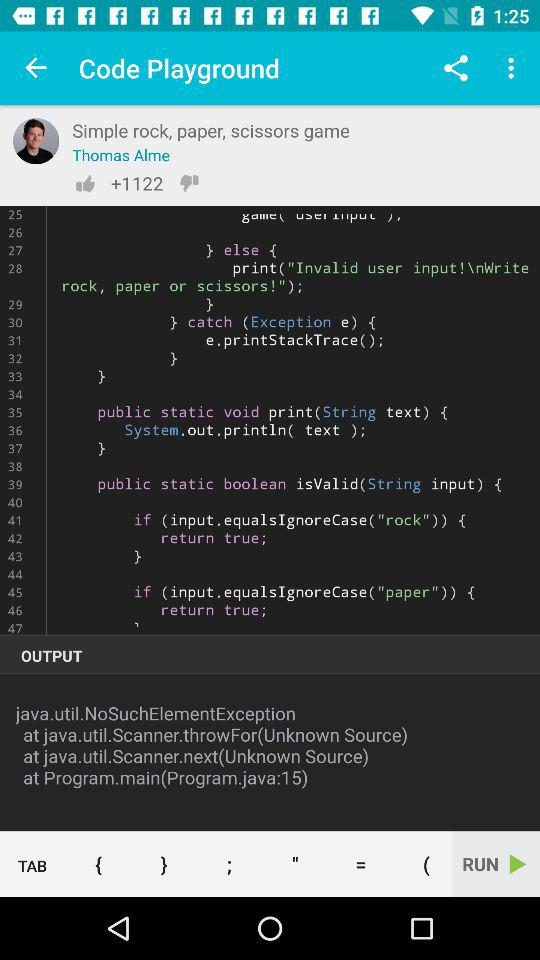How many thumbs up does the user have?
Answer the question using a single word or phrase. 1122 